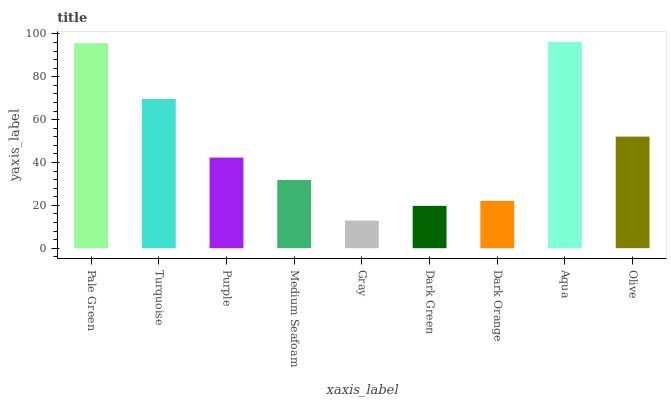Is Gray the minimum?
Answer yes or no. Yes. Is Aqua the maximum?
Answer yes or no. Yes. Is Turquoise the minimum?
Answer yes or no. No. Is Turquoise the maximum?
Answer yes or no. No. Is Pale Green greater than Turquoise?
Answer yes or no. Yes. Is Turquoise less than Pale Green?
Answer yes or no. Yes. Is Turquoise greater than Pale Green?
Answer yes or no. No. Is Pale Green less than Turquoise?
Answer yes or no. No. Is Purple the high median?
Answer yes or no. Yes. Is Purple the low median?
Answer yes or no. Yes. Is Gray the high median?
Answer yes or no. No. Is Dark Green the low median?
Answer yes or no. No. 